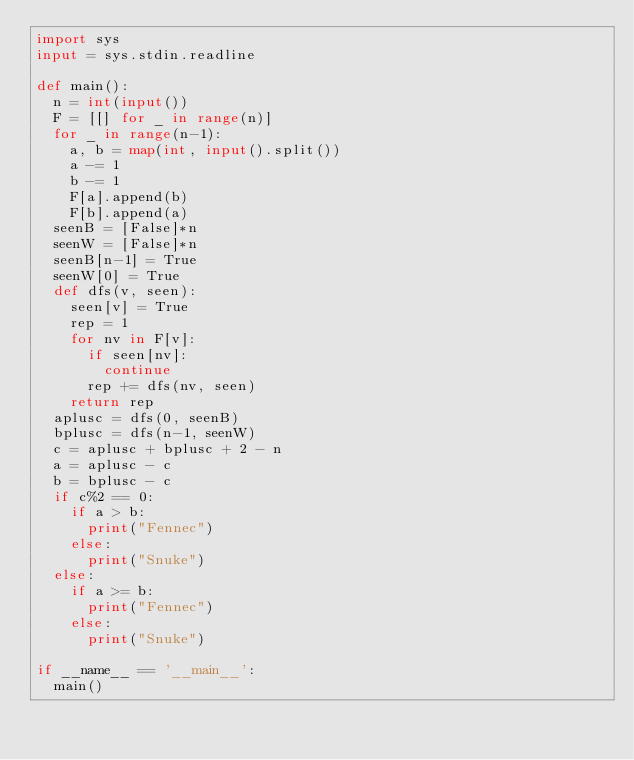Convert code to text. <code><loc_0><loc_0><loc_500><loc_500><_Python_>import sys
input = sys.stdin.readline

def main():
  n = int(input())
  F = [[] for _ in range(n)]
  for _ in range(n-1):
    a, b = map(int, input().split())
    a -= 1
    b -= 1
    F[a].append(b)
    F[b].append(a)
  seenB = [False]*n
  seenW = [False]*n
  seenB[n-1] = True
  seenW[0] = True
  def dfs(v, seen):
    seen[v] = True
    rep = 1
    for nv in F[v]:
      if seen[nv]:
        continue
      rep += dfs(nv, seen)
    return rep
  aplusc = dfs(0, seenB)
  bplusc = dfs(n-1, seenW)
  c = aplusc + bplusc + 2 - n
  a = aplusc - c
  b = bplusc - c
  if c%2 == 0:
    if a > b:
      print("Fennec")
    else:
      print("Snuke")
  else:
    if a >= b:
      print("Fennec")
    else:
      print("Snuke")
      
if __name__ == '__main__':
  main()</code> 